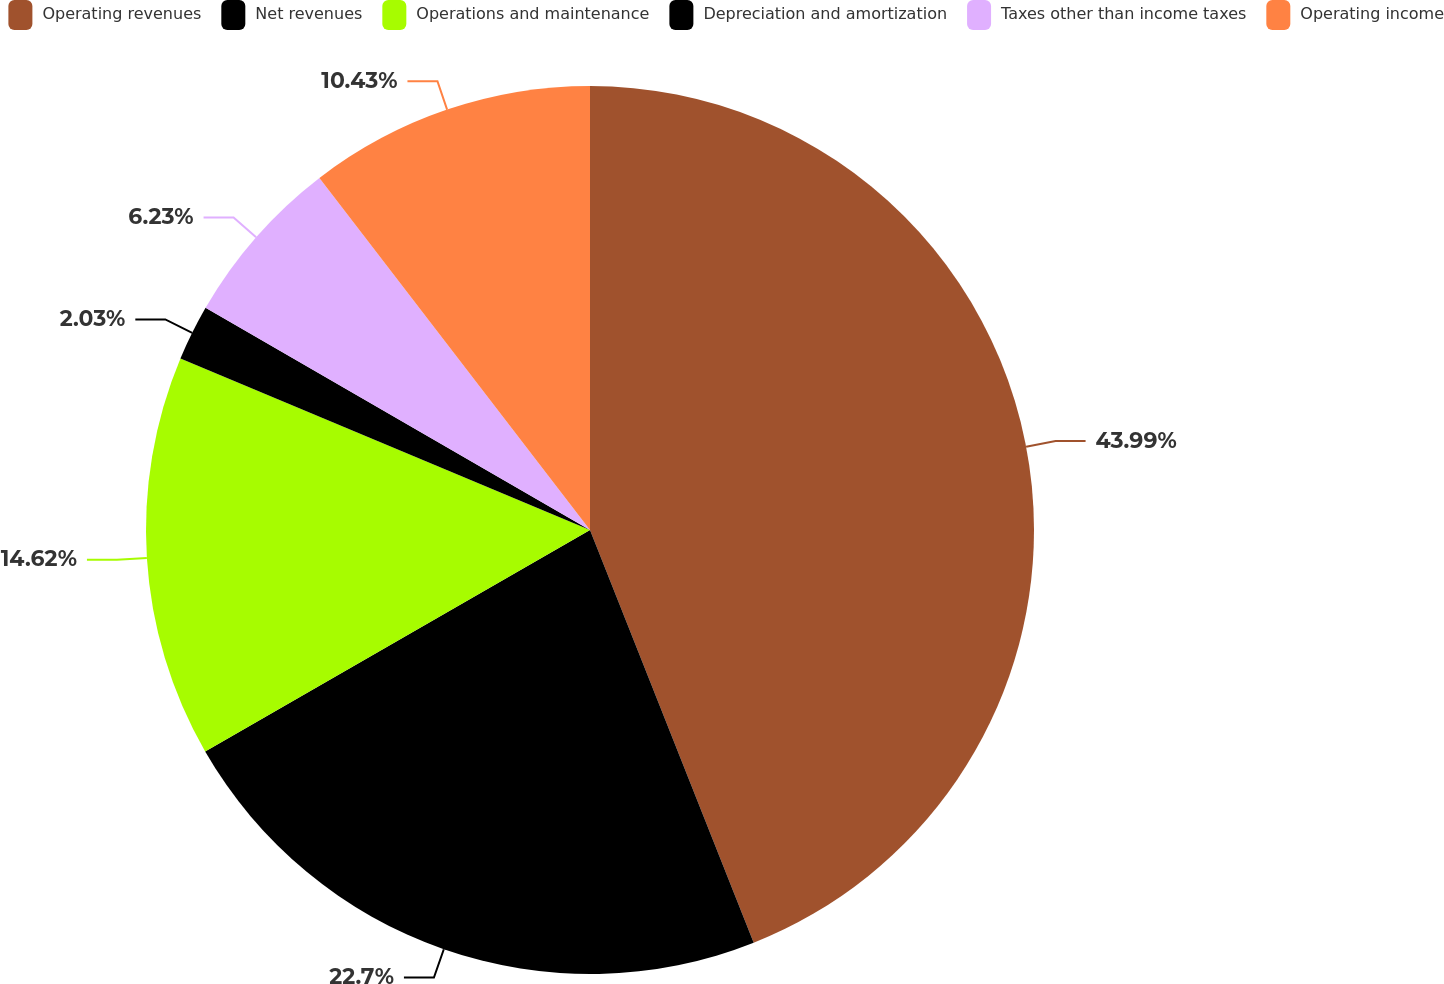<chart> <loc_0><loc_0><loc_500><loc_500><pie_chart><fcel>Operating revenues<fcel>Net revenues<fcel>Operations and maintenance<fcel>Depreciation and amortization<fcel>Taxes other than income taxes<fcel>Operating income<nl><fcel>43.99%<fcel>22.7%<fcel>14.62%<fcel>2.03%<fcel>6.23%<fcel>10.43%<nl></chart> 